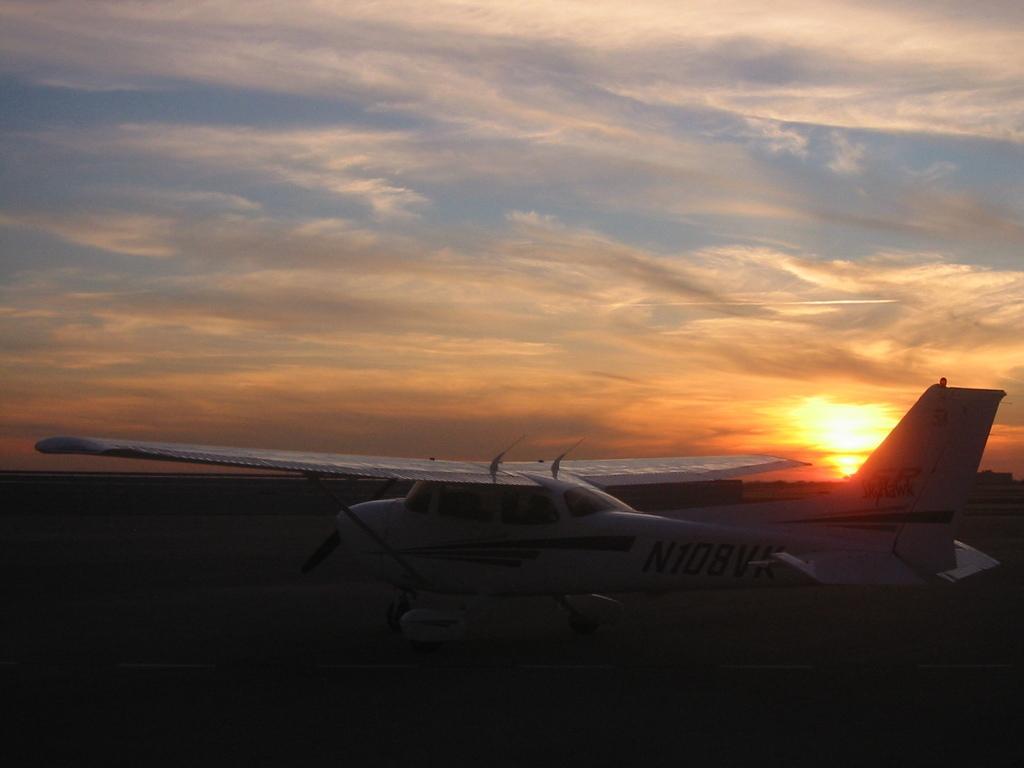Please provide a concise description of this image. In this image I see an aircraft and in the background I see the sky and the sun. 